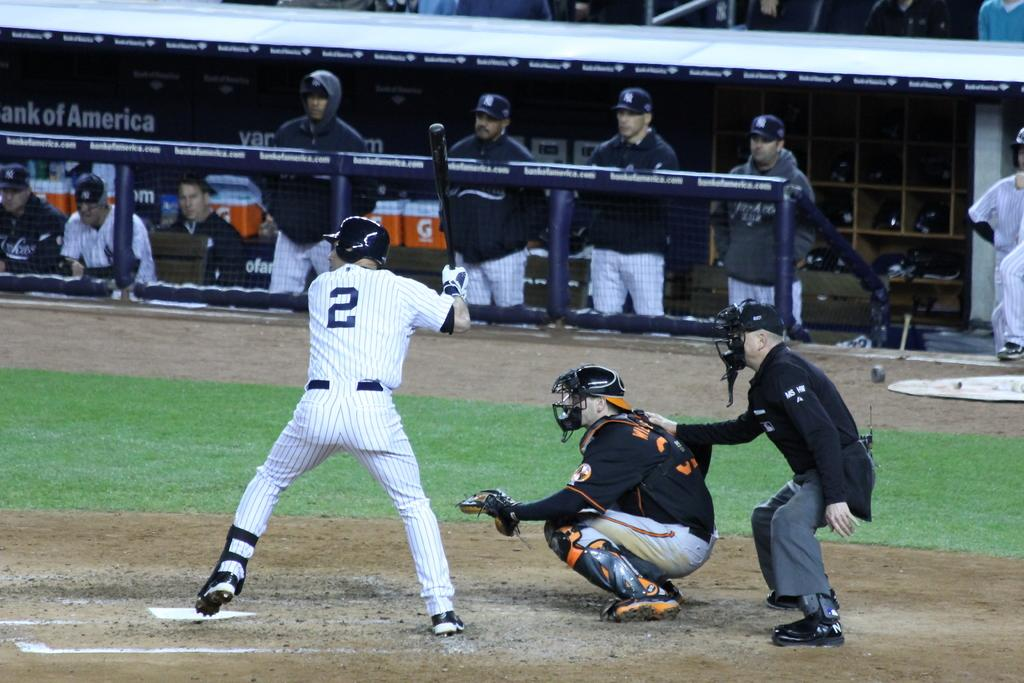<image>
Relay a brief, clear account of the picture shown. Baseball players on a field, batter number 2 is batting, the players on the side are in a stand sponsored by Bank of America. 